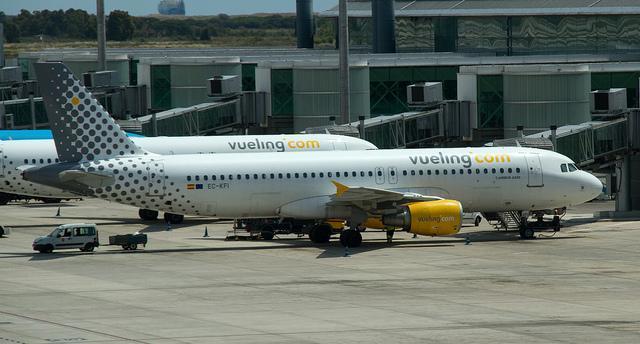How many airplanes are visible?
Give a very brief answer. 2. How many bears are white?
Give a very brief answer. 0. 